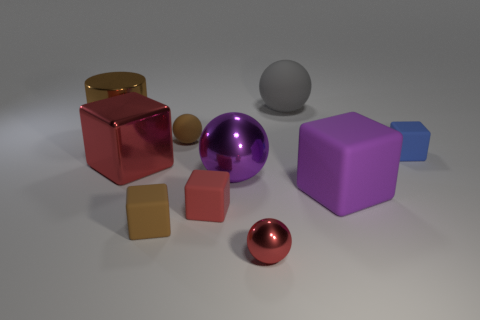Subtract 2 balls. How many balls are left? 2 Subtract all brown balls. How many balls are left? 3 Subtract all gray spheres. How many spheres are left? 3 Subtract all blue cubes. Subtract all cyan cylinders. How many cubes are left? 4 Add 10 big brown matte balls. How many big brown matte balls exist? 10 Subtract 0 green blocks. How many objects are left? 10 Subtract all balls. How many objects are left? 6 Subtract all tiny brown balls. Subtract all large rubber objects. How many objects are left? 7 Add 1 red blocks. How many red blocks are left? 3 